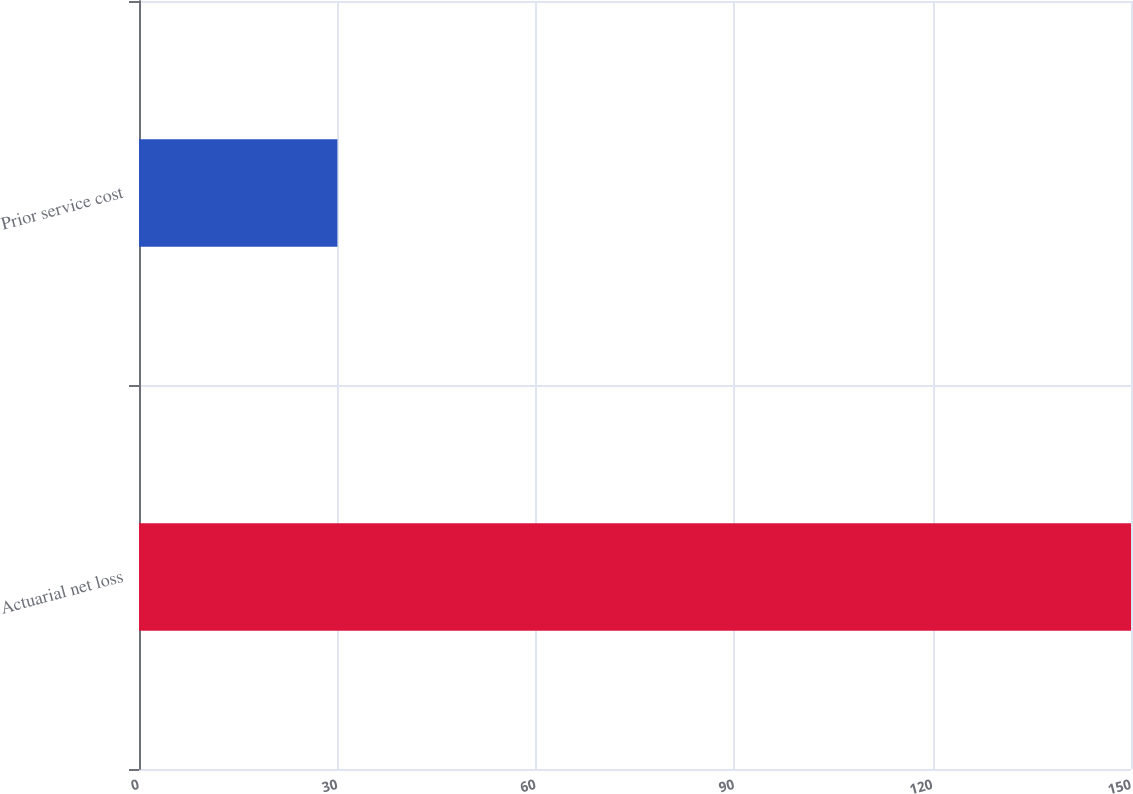Convert chart to OTSL. <chart><loc_0><loc_0><loc_500><loc_500><bar_chart><fcel>Actuarial net loss<fcel>Prior service cost<nl><fcel>150<fcel>30<nl></chart> 